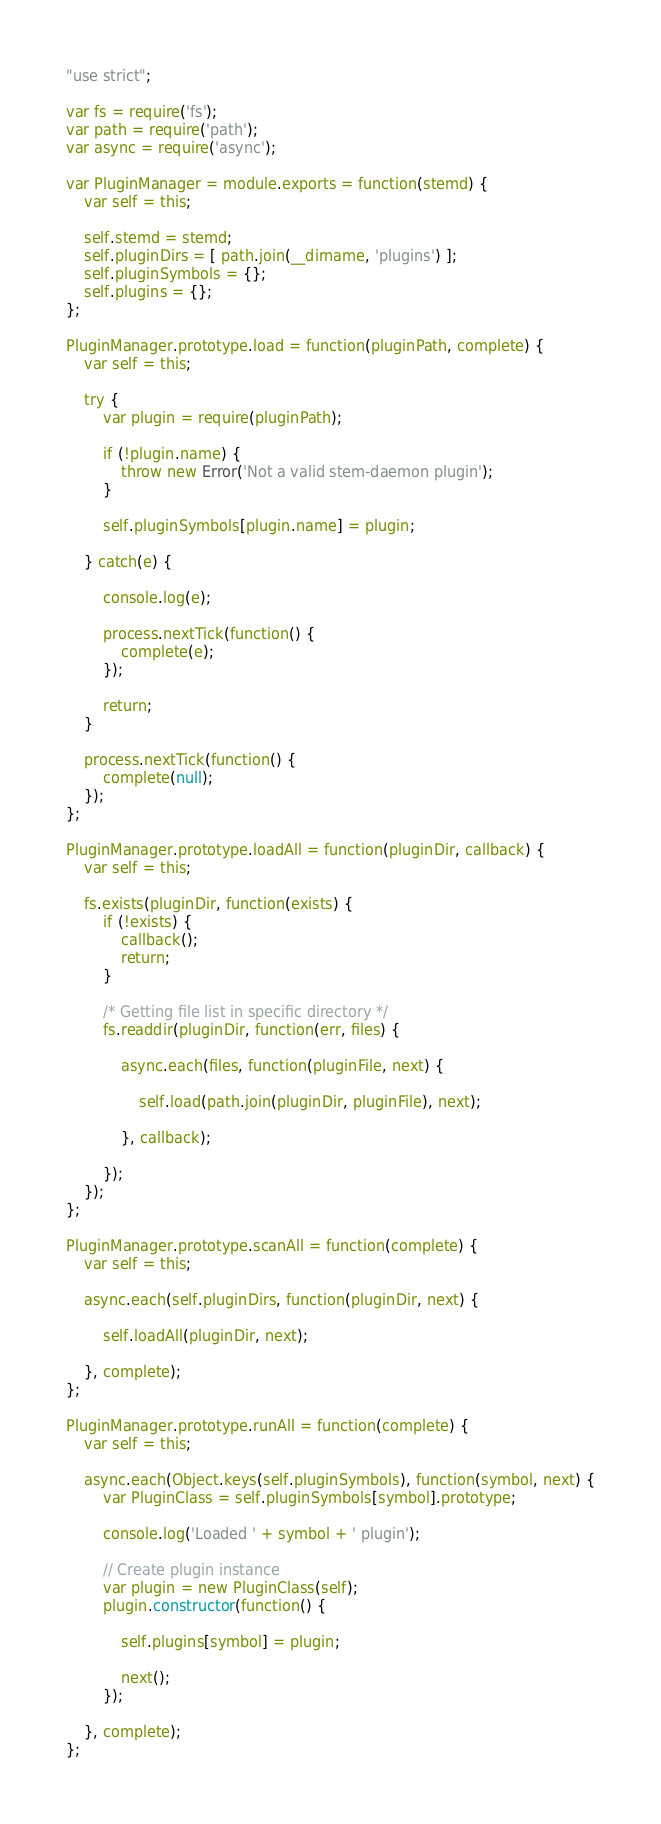Convert code to text. <code><loc_0><loc_0><loc_500><loc_500><_JavaScript_>"use strict";

var fs = require('fs');
var path = require('path');
var async = require('async');

var PluginManager = module.exports = function(stemd) {
	var self = this;

	self.stemd = stemd;
	self.pluginDirs = [ path.join(__dirname, 'plugins') ];
	self.pluginSymbols = {};
	self.plugins = {};
};

PluginManager.prototype.load = function(pluginPath, complete) {
	var self = this;

	try {
		var plugin = require(pluginPath);

		if (!plugin.name) {
			throw new Error('Not a valid stem-daemon plugin');
		}

		self.pluginSymbols[plugin.name] = plugin;

	} catch(e) {

		console.log(e);

		process.nextTick(function() {
			complete(e);
		});

		return;
	}

	process.nextTick(function() {
		complete(null);
	});
};

PluginManager.prototype.loadAll = function(pluginDir, callback) {
	var self = this;

	fs.exists(pluginDir, function(exists) {
		if (!exists) {
			callback();
			return;
		}

		/* Getting file list in specific directory */
		fs.readdir(pluginDir, function(err, files) {

			async.each(files, function(pluginFile, next) {

				self.load(path.join(pluginDir, pluginFile), next);

			}, callback);

		});
	});
};

PluginManager.prototype.scanAll = function(complete) {
	var self = this;

	async.each(self.pluginDirs, function(pluginDir, next) {

		self.loadAll(pluginDir, next);

	}, complete);
};

PluginManager.prototype.runAll = function(complete) {
	var self = this;

	async.each(Object.keys(self.pluginSymbols), function(symbol, next) {
		var PluginClass = self.pluginSymbols[symbol].prototype;

		console.log('Loaded ' + symbol + ' plugin');

		// Create plugin instance
		var plugin = new PluginClass(self);
		plugin.constructor(function() {

			self.plugins[symbol] = plugin;

			next();
		});
		
	}, complete);
};

</code> 